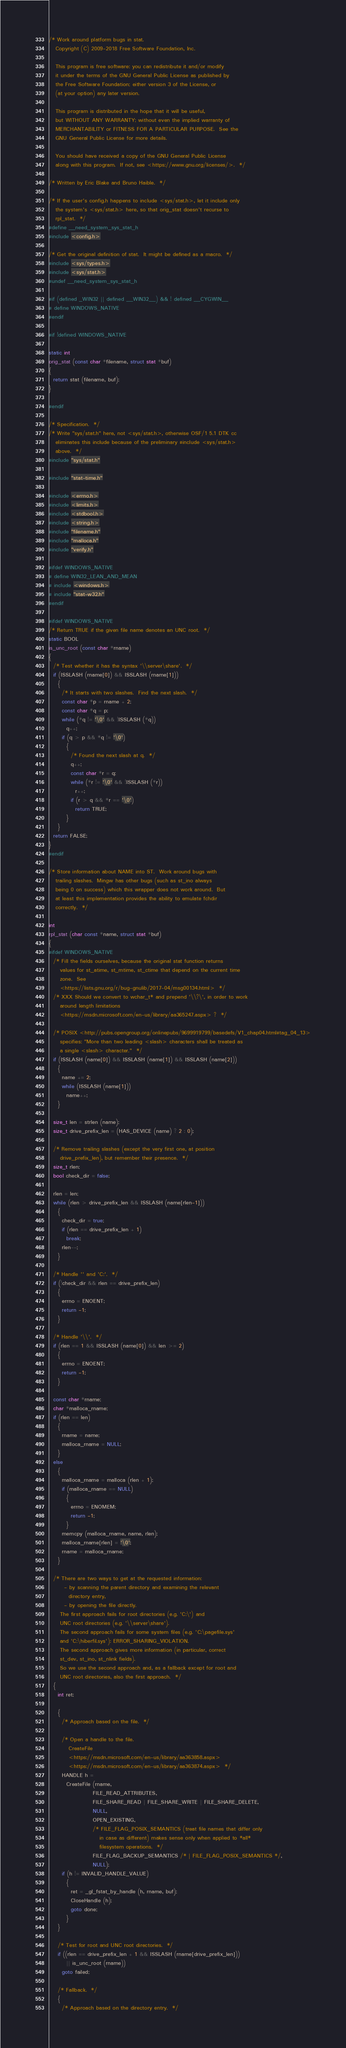<code> <loc_0><loc_0><loc_500><loc_500><_C_>/* Work around platform bugs in stat.
   Copyright (C) 2009-2018 Free Software Foundation, Inc.

   This program is free software: you can redistribute it and/or modify
   it under the terms of the GNU General Public License as published by
   the Free Software Foundation; either version 3 of the License, or
   (at your option) any later version.

   This program is distributed in the hope that it will be useful,
   but WITHOUT ANY WARRANTY; without even the implied warranty of
   MERCHANTABILITY or FITNESS FOR A PARTICULAR PURPOSE.  See the
   GNU General Public License for more details.

   You should have received a copy of the GNU General Public License
   along with this program.  If not, see <https://www.gnu.org/licenses/>.  */

/* Written by Eric Blake and Bruno Haible.  */

/* If the user's config.h happens to include <sys/stat.h>, let it include only
   the system's <sys/stat.h> here, so that orig_stat doesn't recurse to
   rpl_stat.  */
#define __need_system_sys_stat_h
#include <config.h>

/* Get the original definition of stat.  It might be defined as a macro.  */
#include <sys/types.h>
#include <sys/stat.h>
#undef __need_system_sys_stat_h

#if (defined _WIN32 || defined __WIN32__) && ! defined __CYGWIN__
# define WINDOWS_NATIVE
#endif

#if !defined WINDOWS_NATIVE

static int
orig_stat (const char *filename, struct stat *buf)
{
  return stat (filename, buf);
}

#endif

/* Specification.  */
/* Write "sys/stat.h" here, not <sys/stat.h>, otherwise OSF/1 5.1 DTK cc
   eliminates this include because of the preliminary #include <sys/stat.h>
   above.  */
#include "sys/stat.h"

#include "stat-time.h"

#include <errno.h>
#include <limits.h>
#include <stdbool.h>
#include <string.h>
#include "filename.h"
#include "malloca.h"
#include "verify.h"

#ifdef WINDOWS_NATIVE
# define WIN32_LEAN_AND_MEAN
# include <windows.h>
# include "stat-w32.h"
#endif

#ifdef WINDOWS_NATIVE
/* Return TRUE if the given file name denotes an UNC root.  */
static BOOL
is_unc_root (const char *rname)
{
  /* Test whether it has the syntax '\\server\share'.  */
  if (ISSLASH (rname[0]) && ISSLASH (rname[1]))
    {
      /* It starts with two slashes.  Find the next slash.  */
      const char *p = rname + 2;
      const char *q = p;
      while (*q != '\0' && !ISSLASH (*q))
        q++;
      if (q > p && *q != '\0')
        {
          /* Found the next slash at q.  */
          q++;
          const char *r = q;
          while (*r != '\0' && !ISSLASH (*r))
            r++;
          if (r > q && *r == '\0')
            return TRUE;
        }
    }
  return FALSE;
}
#endif

/* Store information about NAME into ST.  Work around bugs with
   trailing slashes.  Mingw has other bugs (such as st_ino always
   being 0 on success) which this wrapper does not work around.  But
   at least this implementation provides the ability to emulate fchdir
   correctly.  */

int
rpl_stat (char const *name, struct stat *buf)
{
#ifdef WINDOWS_NATIVE
  /* Fill the fields ourselves, because the original stat function returns
     values for st_atime, st_mtime, st_ctime that depend on the current time
     zone.  See
     <https://lists.gnu.org/r/bug-gnulib/2017-04/msg00134.html>  */
  /* XXX Should we convert to wchar_t* and prepend '\\?\', in order to work
     around length limitations
     <https://msdn.microsoft.com/en-us/library/aa365247.aspx> ?  */

  /* POSIX <http://pubs.opengroup.org/onlinepubs/9699919799/basedefs/V1_chap04.html#tag_04_13>
     specifies: "More than two leading <slash> characters shall be treated as
     a single <slash> character."  */
  if (ISSLASH (name[0]) && ISSLASH (name[1]) && ISSLASH (name[2]))
    {
      name += 2;
      while (ISSLASH (name[1]))
        name++;
    }

  size_t len = strlen (name);
  size_t drive_prefix_len = (HAS_DEVICE (name) ? 2 : 0);

  /* Remove trailing slashes (except the very first one, at position
     drive_prefix_len), but remember their presence.  */
  size_t rlen;
  bool check_dir = false;

  rlen = len;
  while (rlen > drive_prefix_len && ISSLASH (name[rlen-1]))
    {
      check_dir = true;
      if (rlen == drive_prefix_len + 1)
        break;
      rlen--;
    }

  /* Handle '' and 'C:'.  */
  if (!check_dir && rlen == drive_prefix_len)
    {
      errno = ENOENT;
      return -1;
    }

  /* Handle '\\'.  */
  if (rlen == 1 && ISSLASH (name[0]) && len >= 2)
    {
      errno = ENOENT;
      return -1;
    }

  const char *rname;
  char *malloca_rname;
  if (rlen == len)
    {
      rname = name;
      malloca_rname = NULL;
    }
  else
    {
      malloca_rname = malloca (rlen + 1);
      if (malloca_rname == NULL)
        {
          errno = ENOMEM;
          return -1;
        }
      memcpy (malloca_rname, name, rlen);
      malloca_rname[rlen] = '\0';
      rname = malloca_rname;
    }

  /* There are two ways to get at the requested information:
       - by scanning the parent directory and examining the relevant
         directory entry,
       - by opening the file directly.
     The first approach fails for root directories (e.g. 'C:\') and
     UNC root directories (e.g. '\\server\share').
     The second approach fails for some system files (e.g. 'C:\pagefile.sys'
     and 'C:\hiberfil.sys'): ERROR_SHARING_VIOLATION.
     The second approach gives more information (in particular, correct
     st_dev, st_ino, st_nlink fields).
     So we use the second approach and, as a fallback except for root and
     UNC root directories, also the first approach.  */
  {
    int ret;

    {
      /* Approach based on the file.  */

      /* Open a handle to the file.
         CreateFile
         <https://msdn.microsoft.com/en-us/library/aa363858.aspx>
         <https://msdn.microsoft.com/en-us/library/aa363874.aspx>  */
      HANDLE h =
        CreateFile (rname,
                    FILE_READ_ATTRIBUTES,
                    FILE_SHARE_READ | FILE_SHARE_WRITE | FILE_SHARE_DELETE,
                    NULL,
                    OPEN_EXISTING,
                    /* FILE_FLAG_POSIX_SEMANTICS (treat file names that differ only
                       in case as different) makes sense only when applied to *all*
                       filesystem operations.  */
                    FILE_FLAG_BACKUP_SEMANTICS /* | FILE_FLAG_POSIX_SEMANTICS */,
                    NULL);
      if (h != INVALID_HANDLE_VALUE)
        {
          ret = _gl_fstat_by_handle (h, rname, buf);
          CloseHandle (h);
          goto done;
        }
    }

    /* Test for root and UNC root directories.  */
    if ((rlen == drive_prefix_len + 1 && ISSLASH (rname[drive_prefix_len]))
        || is_unc_root (rname))
      goto failed;

    /* Fallback.  */
    {
      /* Approach based on the directory entry.  */
</code> 